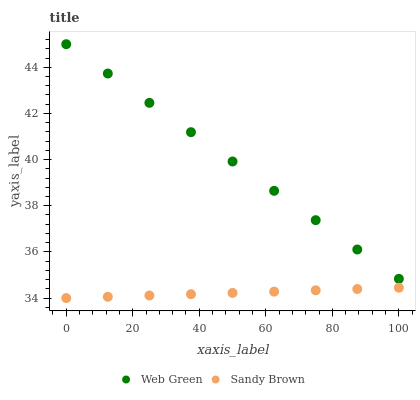Does Sandy Brown have the minimum area under the curve?
Answer yes or no. Yes. Does Web Green have the maximum area under the curve?
Answer yes or no. Yes. Does Web Green have the minimum area under the curve?
Answer yes or no. No. Is Web Green the smoothest?
Answer yes or no. Yes. Is Sandy Brown the roughest?
Answer yes or no. Yes. Is Web Green the roughest?
Answer yes or no. No. Does Sandy Brown have the lowest value?
Answer yes or no. Yes. Does Web Green have the lowest value?
Answer yes or no. No. Does Web Green have the highest value?
Answer yes or no. Yes. Is Sandy Brown less than Web Green?
Answer yes or no. Yes. Is Web Green greater than Sandy Brown?
Answer yes or no. Yes. Does Sandy Brown intersect Web Green?
Answer yes or no. No. 